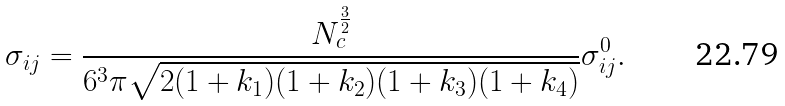Convert formula to latex. <formula><loc_0><loc_0><loc_500><loc_500>\sigma _ { i j } = \frac { N _ { c } ^ { \frac { 3 } { 2 } } } { 6 ^ { 3 } \pi \sqrt { 2 ( 1 + k _ { 1 } ) ( 1 + k _ { 2 } ) ( 1 + k _ { 3 } ) ( 1 + k _ { 4 } ) } } \sigma ^ { 0 } _ { i j } .</formula> 